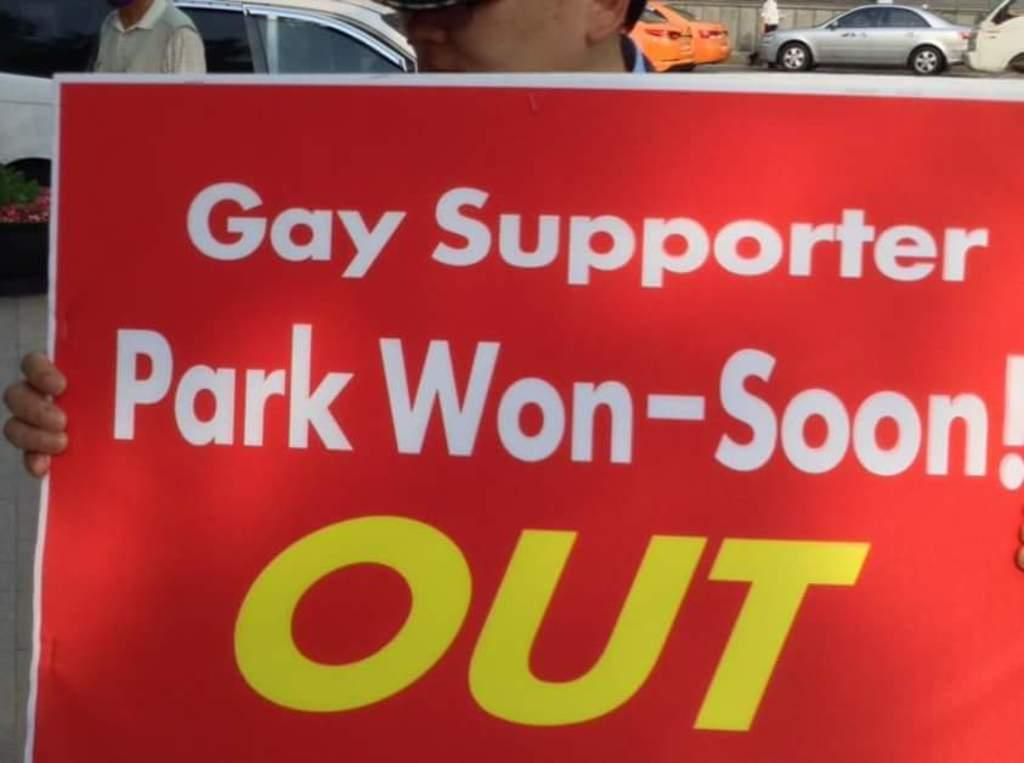What is the person in the image holding? The person is holding a poster in the image. What can be found on the poster? There is text on the poster. What can be seen in the distance in the image? There are vehicles in the background of the image. Are there any other people visible in the image? Yes, there are people in the background of the image. What type of stick is the person using to hold the poster in the image? There is no stick visible in the image; the person is simply holding the poster with their hands. 